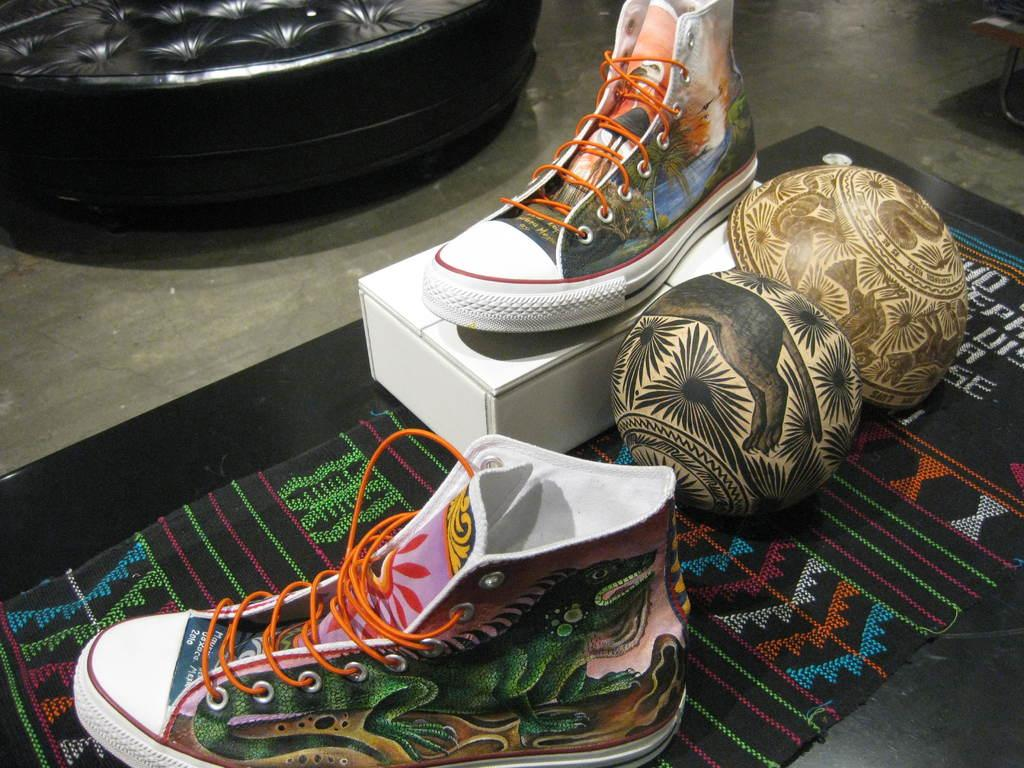What type of footwear is visible in the image? There are shoes in the image. How many bowls are present in the image? There are two bowls in the image. What is on the floor in the image? There is a mat on the floor in the image. What type of seating is in the image? There is a couch in the image. What is the color of the box in the image? There is a white box in the image. Can you see a toothbrush in the image? There is no toothbrush present in the image. What type of drum is visible on the couch in the image? There is no drum present in the image; it only features shoes, bowls, a mat, a couch, and a white box. 